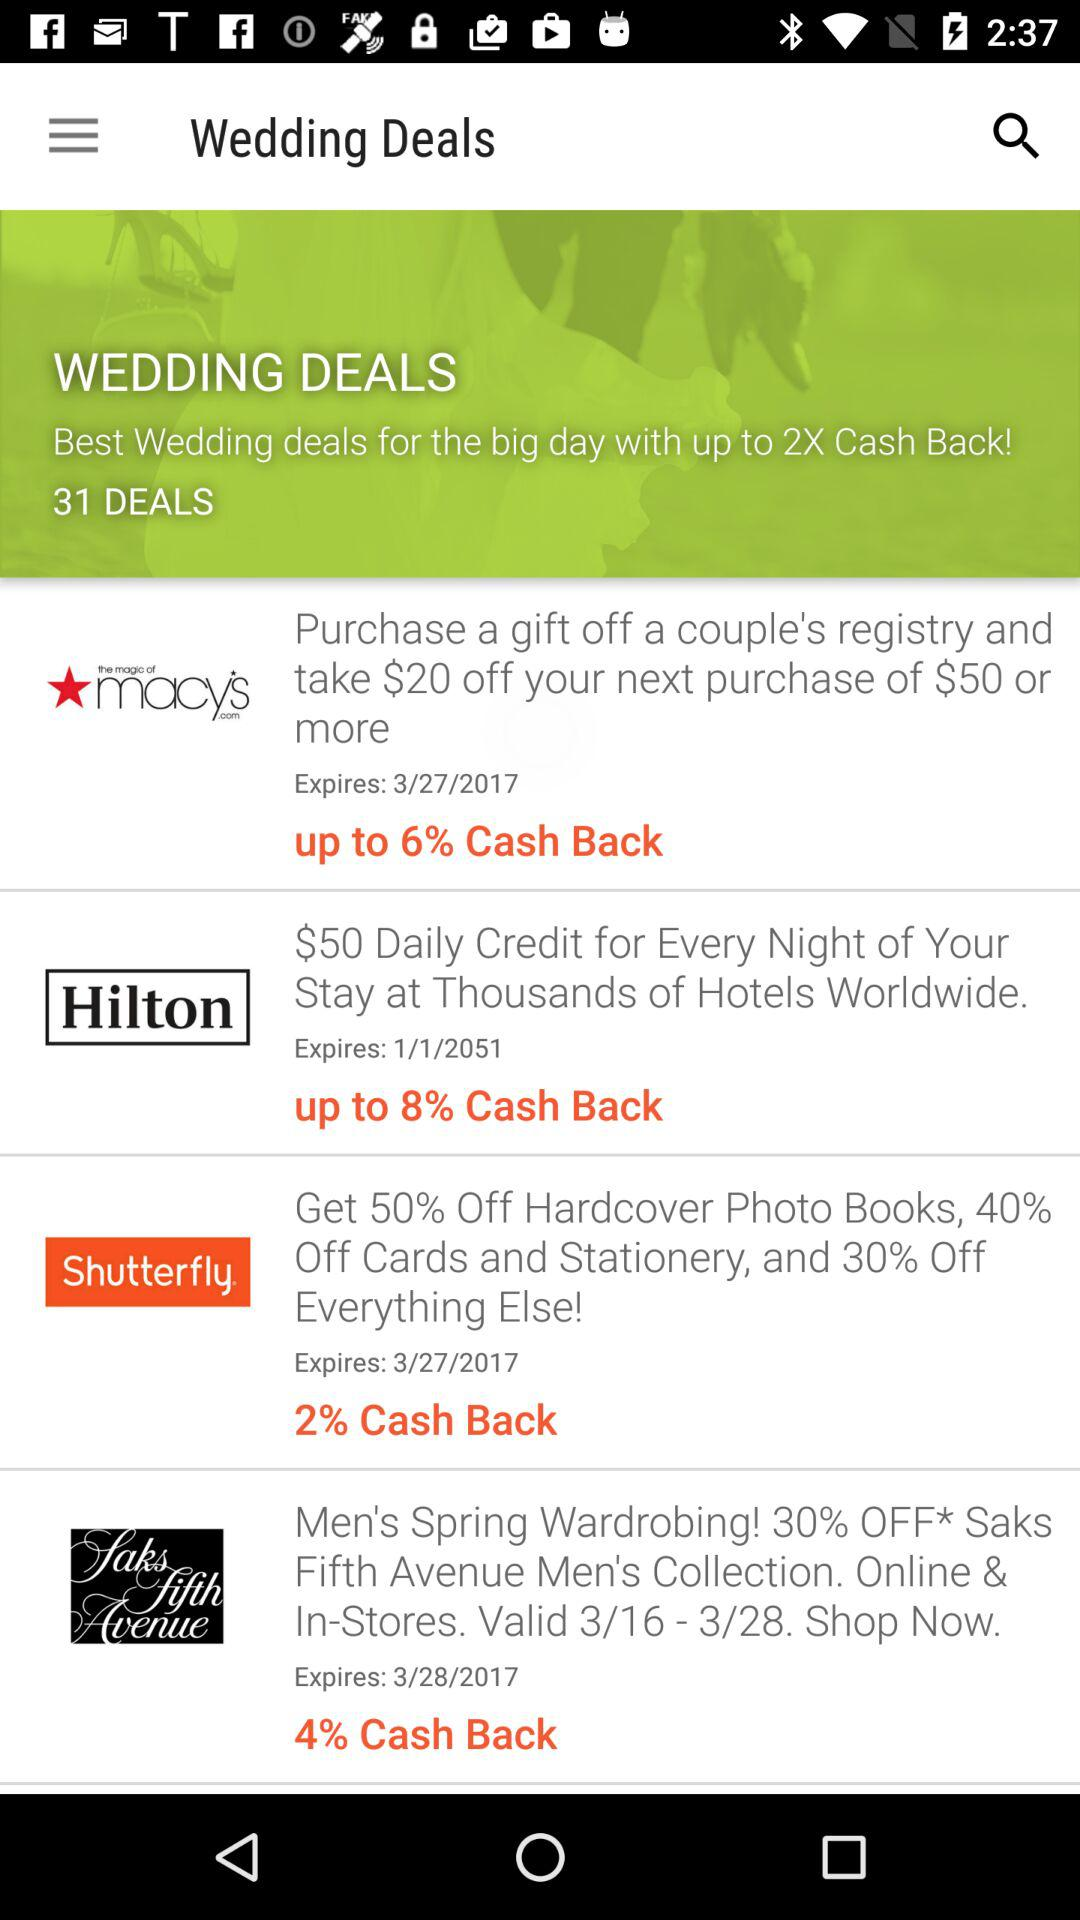How much is off on everything else on "Shutterfly"? There is a discount of 30% on everything else. 